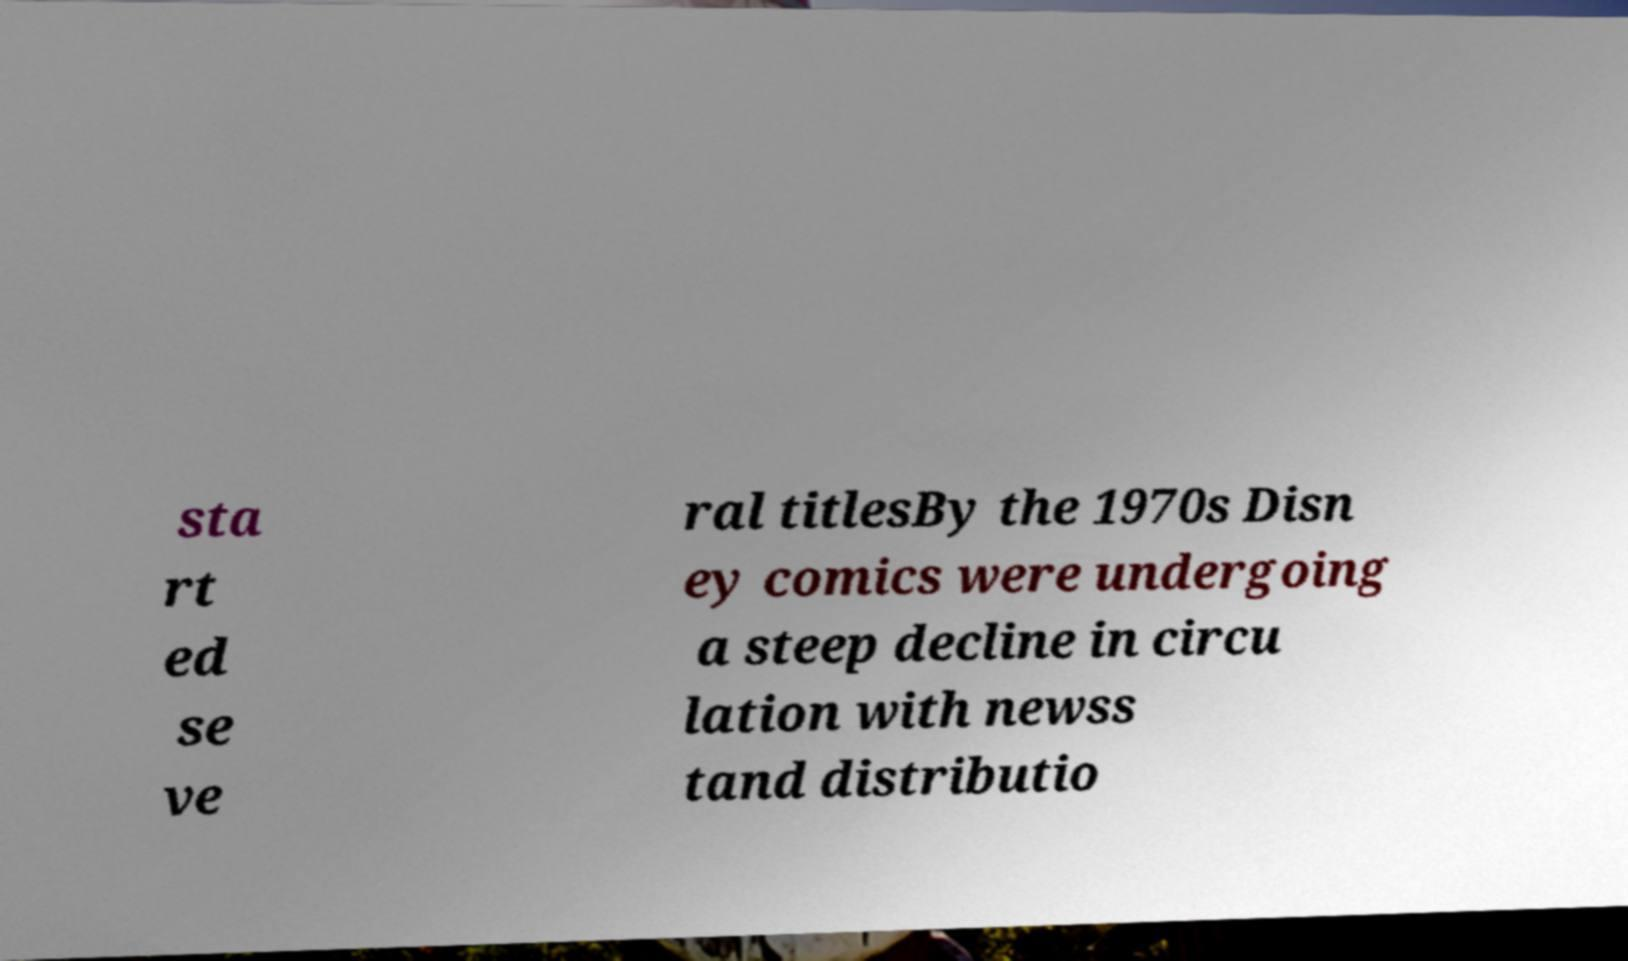Please read and relay the text visible in this image. What does it say? sta rt ed se ve ral titlesBy the 1970s Disn ey comics were undergoing a steep decline in circu lation with newss tand distributio 